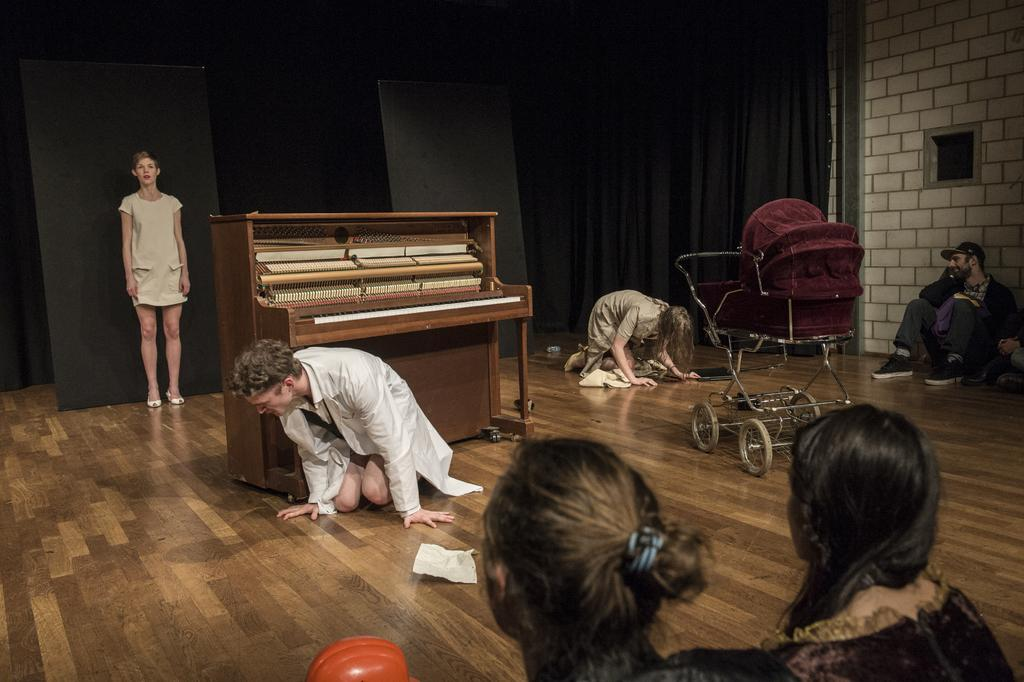What color is the curtain in the image? The curtain is black. What can be seen on the piano in the image? There is a piano keyboard in the image. What type of furniture is present for a baby? There is a baby chair in the image. What position are some people in the image? People are sitting on the floor in the image. How many people can be seen in the image? There is at least one person standing in the image. Can you see the dad playing the piano in the image? There is no dad or piano playing depicted in the image. What type of hook is attached to the baby chair in the image? There is no hook present on the baby chair in the image. 